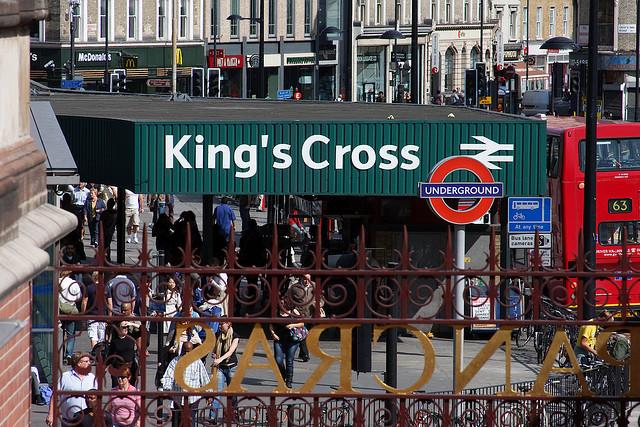What natural force is demonstrated most clearly in this series of pictures?
Give a very brief answer. Gravity. How would you know if there is a subway nearby?
Give a very brief answer. Underground sign. What is the name of the subway station?
Answer briefly. King's cross. What is the number of the double decker bus?
Write a very short answer. 63. 